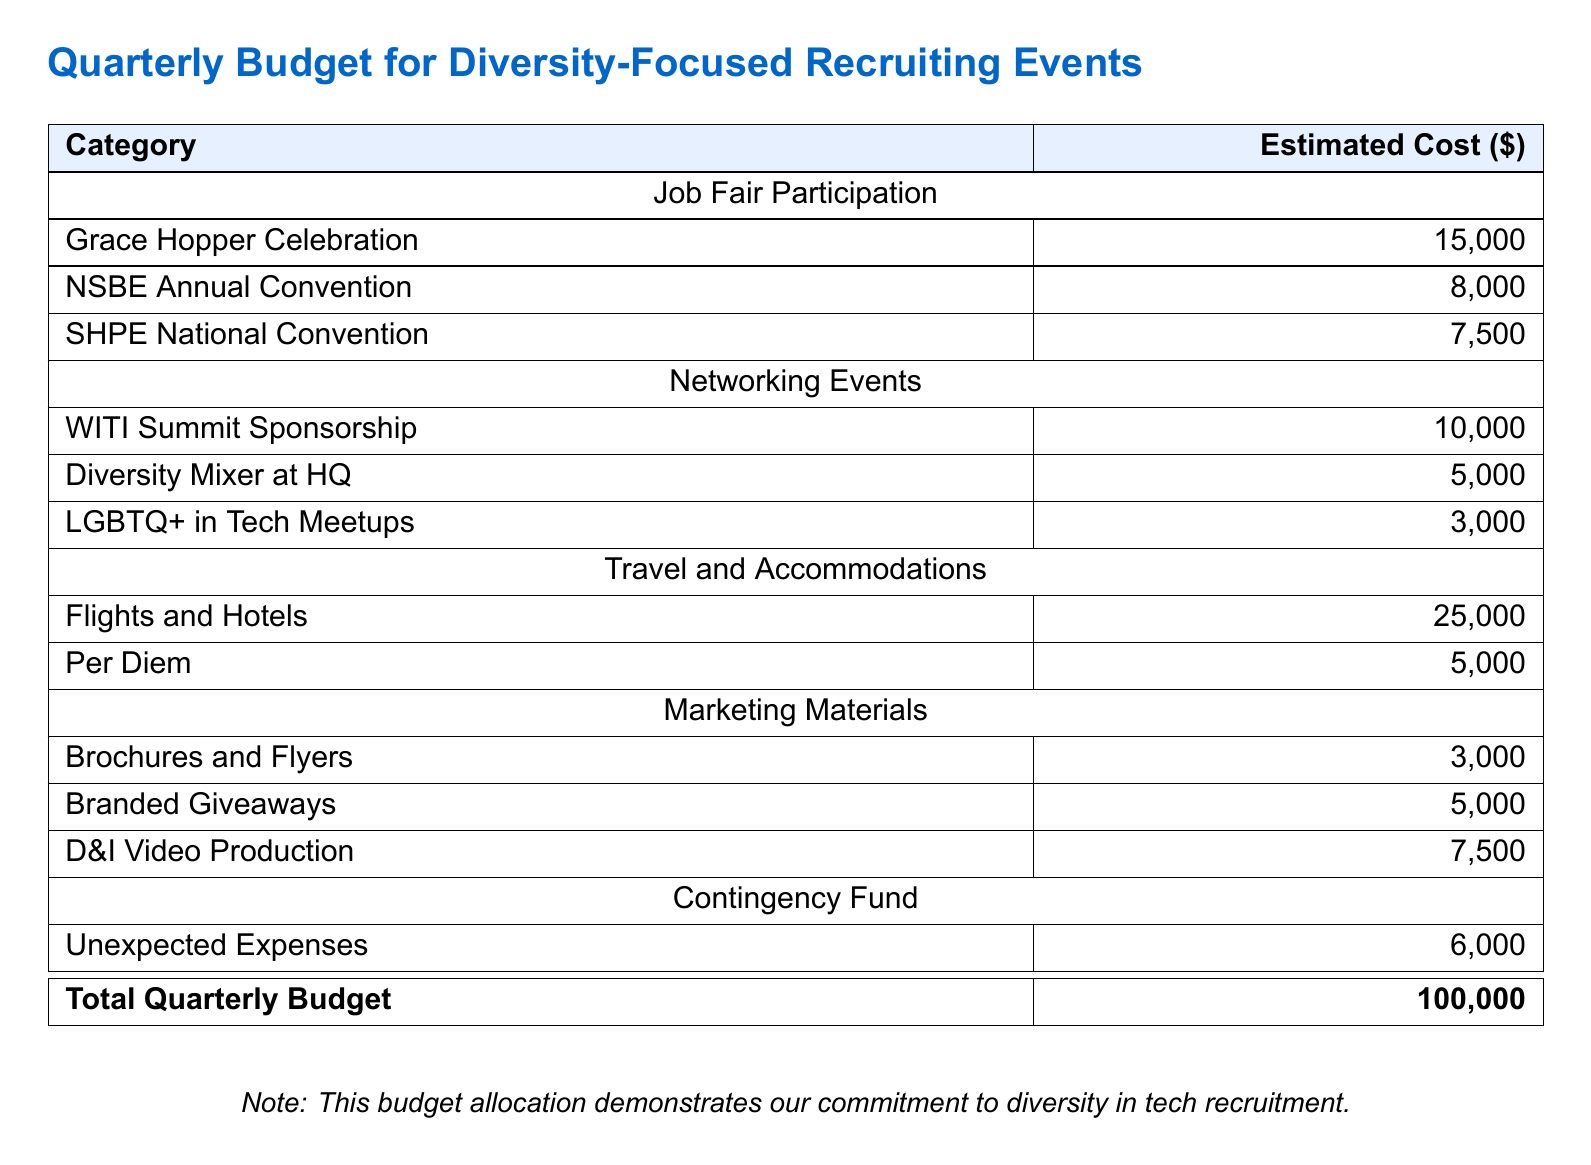What is the total quarterly budget? The total quarterly budget is mentioned at the end of the table, summarizing all estimated costs, which is $100,000.
Answer: $100,000 What is the estimated cost for the Grace Hopper Celebration? The estimated cost for the Grace Hopper Celebration is directly stated in the document, which is $15,000.
Answer: $15,000 How much is allocated for travel and accommodations? The travel and accommodations category has a combined estimated cost of $30,000 (flights, hotels, and per diem).
Answer: $30,000 Which event has the lowest estimated cost? The lowest estimated cost among the listed events is for LGBTQ+ in Tech Meetups, which is $3,000.
Answer: $3,000 What is the estimated cost for branded giveaways? The estimated cost for branded giveaways is explicitly stated in the budget as $5,000.
Answer: $5,000 What is the largest single category of expenses? The largest single category of expenses appears to be travel and accommodations, totaling $30,000.
Answer: Travel and Accommodations How much is allocated for unexpected expenses? The document specifies a contingency fund for unexpected expenses, which is $6,000.
Answer: $6,000 What is the estimated cost for marketing materials? The total for marketing materials, including brochures, flyers, and video production, sums to $15,500.
Answer: $15,500 